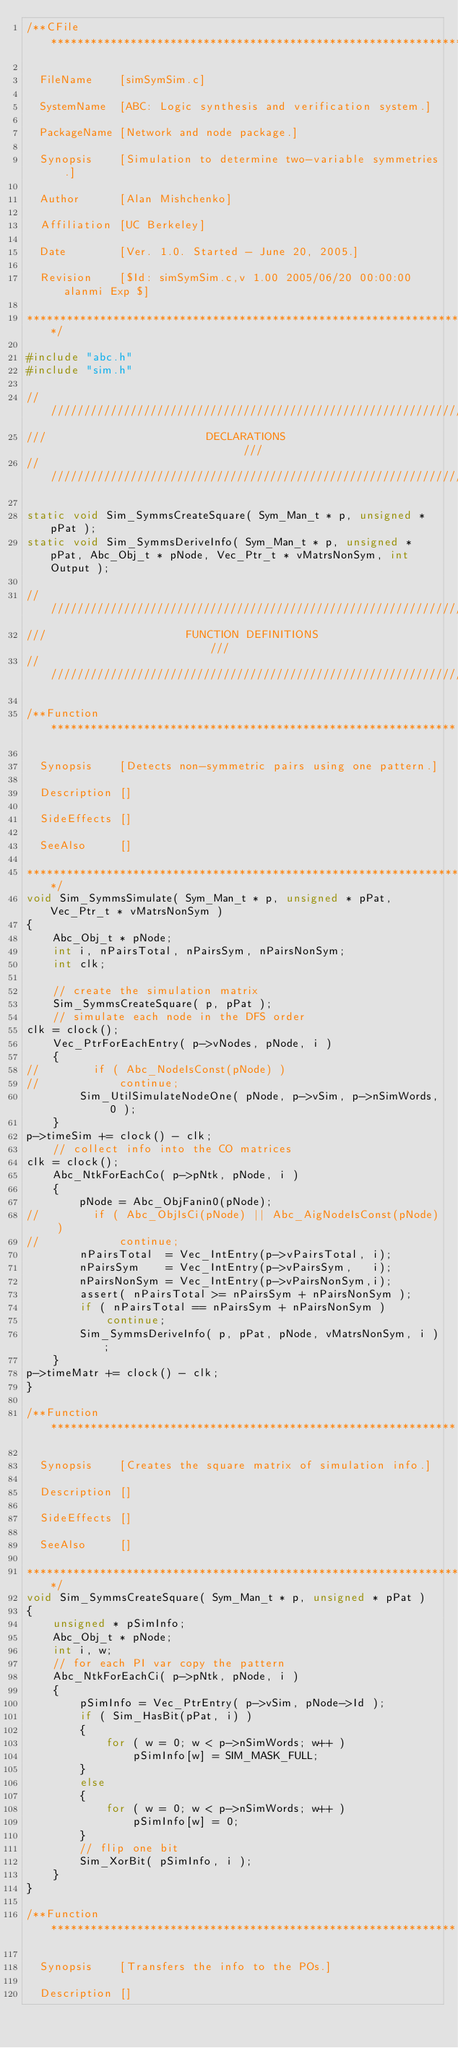<code> <loc_0><loc_0><loc_500><loc_500><_C_>/**CFile****************************************************************

  FileName    [simSymSim.c]

  SystemName  [ABC: Logic synthesis and verification system.]

  PackageName [Network and node package.]

  Synopsis    [Simulation to determine two-variable symmetries.]

  Author      [Alan Mishchenko]
  
  Affiliation [UC Berkeley]

  Date        [Ver. 1.0. Started - June 20, 2005.]

  Revision    [$Id: simSymSim.c,v 1.00 2005/06/20 00:00:00 alanmi Exp $]

***********************************************************************/

#include "abc.h"
#include "sim.h"

////////////////////////////////////////////////////////////////////////
///                        DECLARATIONS                              ///
////////////////////////////////////////////////////////////////////////

static void Sim_SymmsCreateSquare( Sym_Man_t * p, unsigned * pPat );
static void Sim_SymmsDeriveInfo( Sym_Man_t * p, unsigned * pPat, Abc_Obj_t * pNode, Vec_Ptr_t * vMatrsNonSym, int Output );

////////////////////////////////////////////////////////////////////////
///                     FUNCTION DEFINITIONS                         ///
////////////////////////////////////////////////////////////////////////

/**Function*************************************************************

  Synopsis    [Detects non-symmetric pairs using one pattern.]

  Description []
               
  SideEffects []

  SeeAlso     []

***********************************************************************/
void Sim_SymmsSimulate( Sym_Man_t * p, unsigned * pPat, Vec_Ptr_t * vMatrsNonSym )
{
    Abc_Obj_t * pNode;
    int i, nPairsTotal, nPairsSym, nPairsNonSym;
    int clk;

    // create the simulation matrix
    Sim_SymmsCreateSquare( p, pPat );
    // simulate each node in the DFS order
clk = clock();
    Vec_PtrForEachEntry( p->vNodes, pNode, i )
    {
//        if ( Abc_NodeIsConst(pNode) )
//            continue;
        Sim_UtilSimulateNodeOne( pNode, p->vSim, p->nSimWords, 0 );
    }
p->timeSim += clock() - clk;
    // collect info into the CO matrices
clk = clock();
    Abc_NtkForEachCo( p->pNtk, pNode, i )
    {
        pNode = Abc_ObjFanin0(pNode);
//        if ( Abc_ObjIsCi(pNode) || Abc_AigNodeIsConst(pNode) )
//            continue;
        nPairsTotal  = Vec_IntEntry(p->vPairsTotal, i);
        nPairsSym    = Vec_IntEntry(p->vPairsSym,   i);
        nPairsNonSym = Vec_IntEntry(p->vPairsNonSym,i);
        assert( nPairsTotal >= nPairsSym + nPairsNonSym ); 
        if ( nPairsTotal == nPairsSym + nPairsNonSym )
            continue;
        Sim_SymmsDeriveInfo( p, pPat, pNode, vMatrsNonSym, i );
    }
p->timeMatr += clock() - clk;
}

/**Function*************************************************************

  Synopsis    [Creates the square matrix of simulation info.]

  Description []
               
  SideEffects []

  SeeAlso     []

***********************************************************************/
void Sim_SymmsCreateSquare( Sym_Man_t * p, unsigned * pPat )
{
    unsigned * pSimInfo;
    Abc_Obj_t * pNode;
    int i, w;
    // for each PI var copy the pattern
    Abc_NtkForEachCi( p->pNtk, pNode, i )
    {
        pSimInfo = Vec_PtrEntry( p->vSim, pNode->Id );
        if ( Sim_HasBit(pPat, i) )
        {
            for ( w = 0; w < p->nSimWords; w++ )
                pSimInfo[w] = SIM_MASK_FULL;
        }
        else
        {
            for ( w = 0; w < p->nSimWords; w++ )
                pSimInfo[w] = 0;
        }
        // flip one bit
        Sim_XorBit( pSimInfo, i );
    }
}

/**Function*************************************************************

  Synopsis    [Transfers the info to the POs.]

  Description []
               </code> 